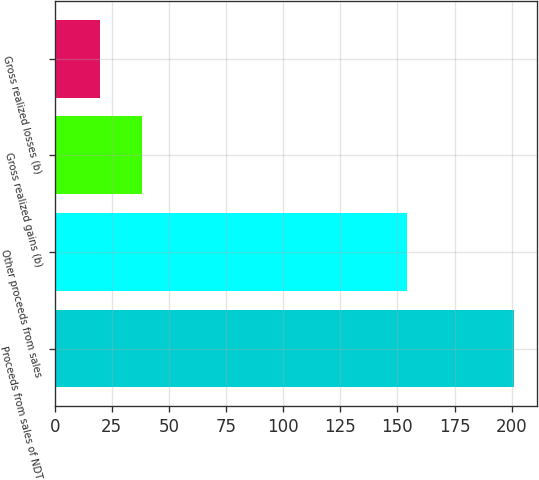Convert chart to OTSL. <chart><loc_0><loc_0><loc_500><loc_500><bar_chart><fcel>Proceeds from sales of NDT<fcel>Other proceeds from sales<fcel>Gross realized gains (b)<fcel>Gross realized losses (b)<nl><fcel>201<fcel>154<fcel>38.1<fcel>20<nl></chart> 